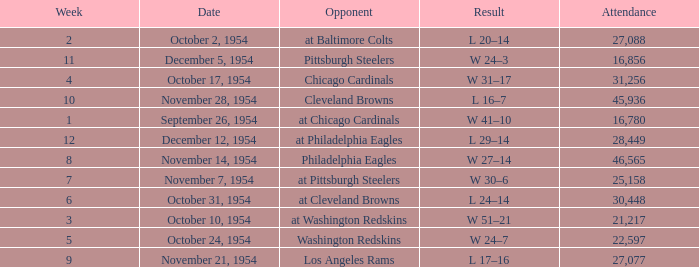How many weeks have october 31, 1954 as the date? 1.0. 